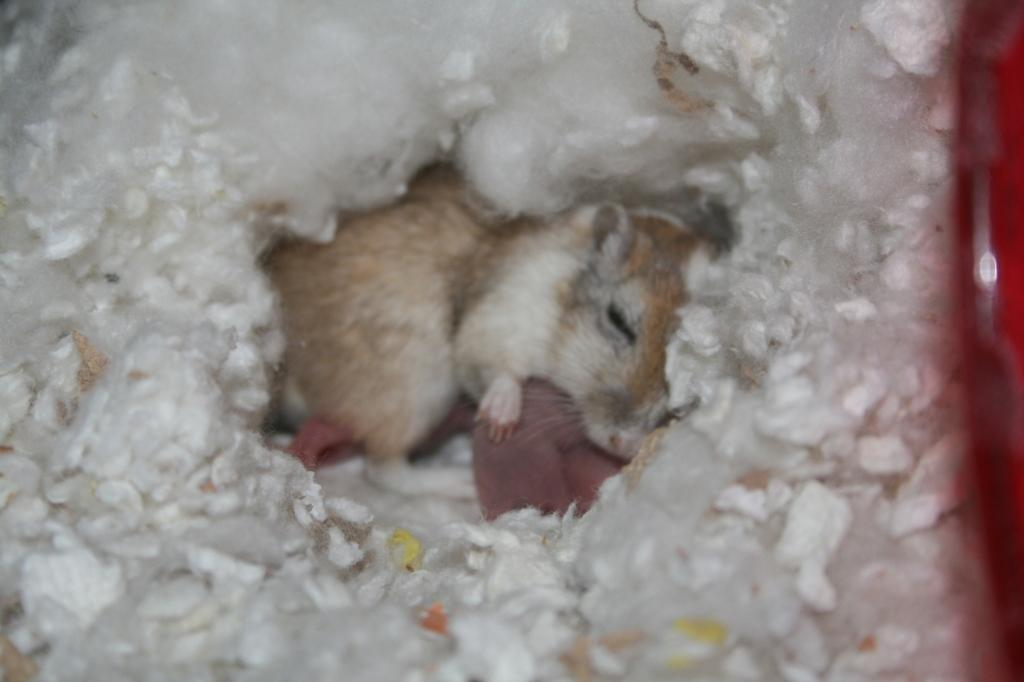What animal is in the middle of the image? There is a rat in the middle of the image. What is surrounding the rat? Cotton is surrounding the rat. What color object can be seen on the right side of the image? There is a red color object on the right side of the image. Can you see the rat smiling in the image? There is no indication of the rat smiling in the image, as rats do not have facial expressions like humans. 